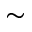Convert formula to latex. <formula><loc_0><loc_0><loc_500><loc_500>\sim</formula> 